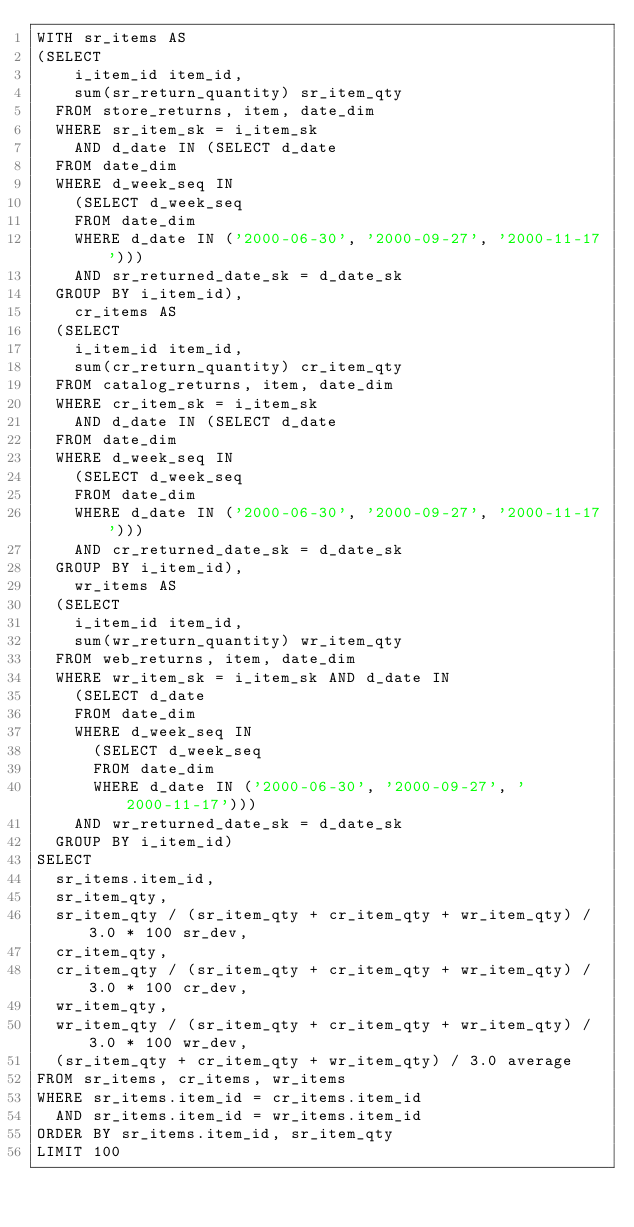Convert code to text. <code><loc_0><loc_0><loc_500><loc_500><_SQL_>WITH sr_items AS
(SELECT
    i_item_id item_id,
    sum(sr_return_quantity) sr_item_qty
  FROM store_returns, item, date_dim
  WHERE sr_item_sk = i_item_sk
    AND d_date IN (SELECT d_date
  FROM date_dim
  WHERE d_week_seq IN
    (SELECT d_week_seq
    FROM date_dim
    WHERE d_date IN ('2000-06-30', '2000-09-27', '2000-11-17')))
    AND sr_returned_date_sk = d_date_sk
  GROUP BY i_item_id),
    cr_items AS
  (SELECT
    i_item_id item_id,
    sum(cr_return_quantity) cr_item_qty
  FROM catalog_returns, item, date_dim
  WHERE cr_item_sk = i_item_sk
    AND d_date IN (SELECT d_date
  FROM date_dim
  WHERE d_week_seq IN
    (SELECT d_week_seq
    FROM date_dim
    WHERE d_date IN ('2000-06-30', '2000-09-27', '2000-11-17')))
    AND cr_returned_date_sk = d_date_sk
  GROUP BY i_item_id),
    wr_items AS
  (SELECT
    i_item_id item_id,
    sum(wr_return_quantity) wr_item_qty
  FROM web_returns, item, date_dim
  WHERE wr_item_sk = i_item_sk AND d_date IN
    (SELECT d_date
    FROM date_dim
    WHERE d_week_seq IN
      (SELECT d_week_seq
      FROM date_dim
      WHERE d_date IN ('2000-06-30', '2000-09-27', '2000-11-17')))
    AND wr_returned_date_sk = d_date_sk
  GROUP BY i_item_id)
SELECT
  sr_items.item_id,
  sr_item_qty,
  sr_item_qty / (sr_item_qty + cr_item_qty + wr_item_qty) / 3.0 * 100 sr_dev,
  cr_item_qty,
  cr_item_qty / (sr_item_qty + cr_item_qty + wr_item_qty) / 3.0 * 100 cr_dev,
  wr_item_qty,
  wr_item_qty / (sr_item_qty + cr_item_qty + wr_item_qty) / 3.0 * 100 wr_dev,
  (sr_item_qty + cr_item_qty + wr_item_qty) / 3.0 average
FROM sr_items, cr_items, wr_items
WHERE sr_items.item_id = cr_items.item_id
  AND sr_items.item_id = wr_items.item_id
ORDER BY sr_items.item_id, sr_item_qty
LIMIT 100
</code> 